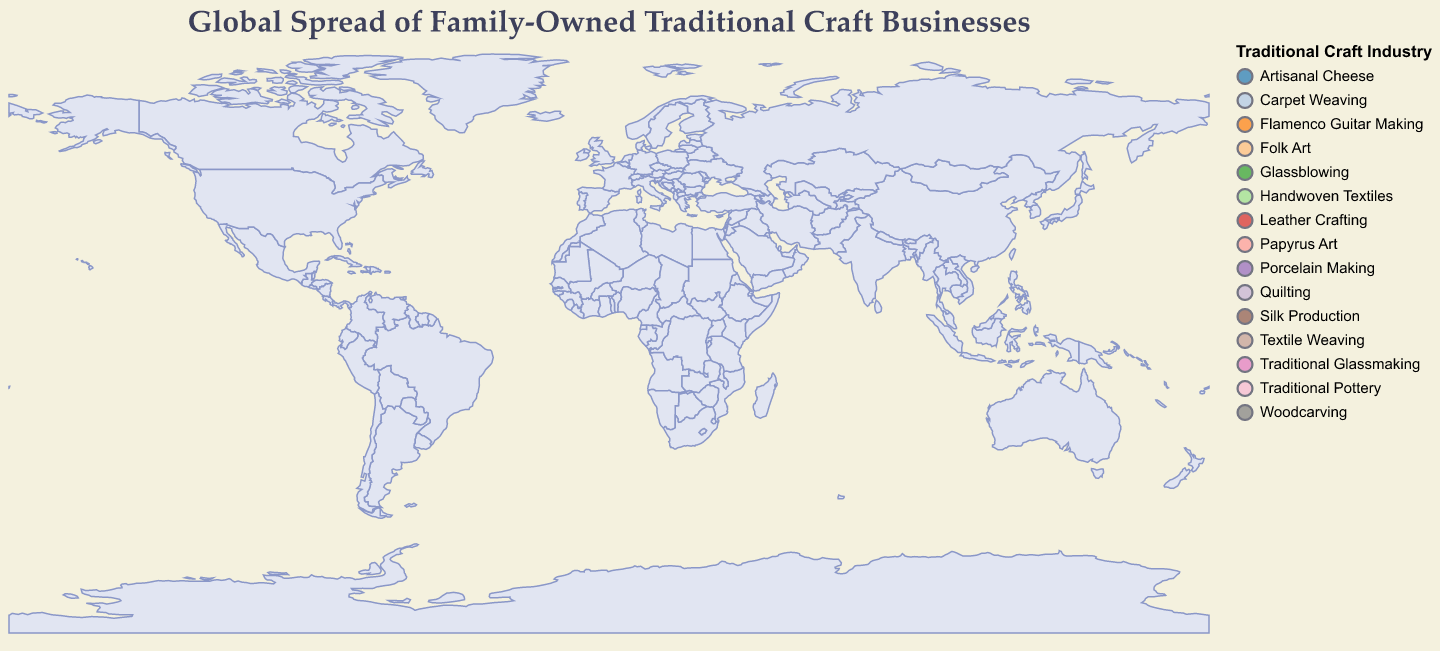How many countries in the dataset have family-owned businesses specializing in traditional crafts? The figure shows one data point per country with family-owned businesses specializing in traditional crafts. By counting the circles, we identify the number of countries.
Answer: 15 Which country has the highest percentage of family-owned businesses in traditional crafts? By examining the size of the circles (which represents the percentage), we identify that India has the largest circle, indicating the highest percentage.
Answer: India What is the total percentage of family-owned businesses in traditional crafts for Japan and China combined? Japan has 15.2% and China has 16.8%. Summing these two percentages gives us the combined total. 15.2 + 16.8 = 32
Answer: 32% How does the percentage of family-owned traditional crafts in Peru compare with that of Morocco? The percentages are given as 10.4% for Peru and 13.5% for Morocco. Comparing these two, Morocco has a higher percentage than Peru.
Answer: Morocco is higher Which industry is represented by the largest and the smallest circles, and where are they located? The largest circle corresponds to Handwoven Textiles in India (18.7%), and the smallest circle corresponds to Quilting in the United States (5.7%).
Answer: Largest: Handwoven Textiles in India, Smallest: Quilting in the USA How many countries have a family-owned business percentage greater than 10%? By examining the circle sizes against the scale legend, we identify the countries that have percentages greater than 10%. These countries are Italy, Japan, India, Turkey, Morocco, China, Peru, and Thailand, summing up to 8 countries.
Answer: 8 Which traditional craft industries are present in both Europe and Asia? By identifying the continents and the industries represented in each country, we see that Europe has Traditional Glassmaking, Artisanal Cheese, and Woodcarving while Asia has Traditional Pottery, Handwoven Textiles, Porcelain Making, and Silk Production. Both continents do not share any specific industry.
Answer: None What is the average percentage of family-owned traditional crafts businesses among European countries? The European countries are Italy (12.5%), France (11.6%), Germany (8.9%), Spain (6.5%), and Sweden (7.2%). Summing these percentages and dividing by the number of countries gives the average: (12.5 + 11.6 + 8.9 + 6.5 + 7.2) / 5 = 9.34
Answer: 9.34% What is the total number of continents represented in the data? The data lists countries from Europe, Asia, North America, Africa, and South America. By counting these distinct continents, we confirm there are 5 represented.
Answer: 5 